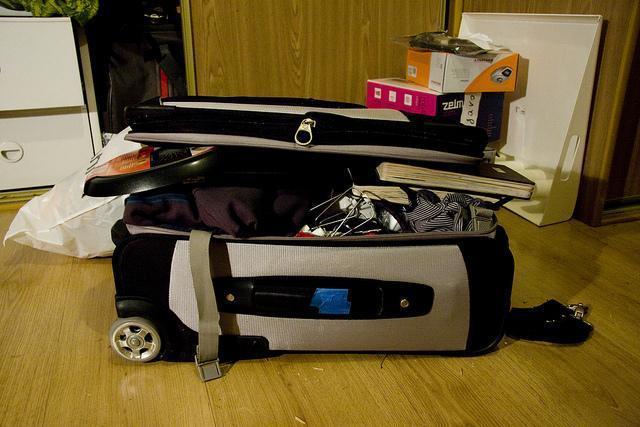How many pieces of luggage are there?
Give a very brief answer. 1. How many people are on the bus?
Give a very brief answer. 0. 